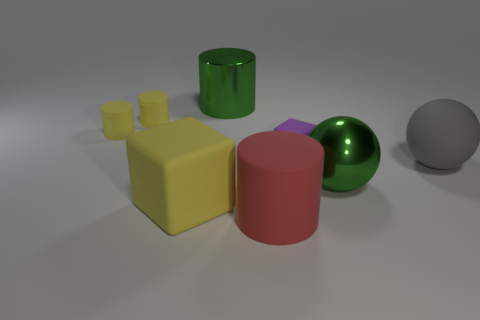Can you describe the lightning conditions in the scene? The lighting in the scene is soft and diffused, suggesting either an overcast outdoor light or a well-lit indoor environment. There are subtle shadows beneath the objects, indicating the light source is positioned above them, resulting in an evenly illuminated composition. 